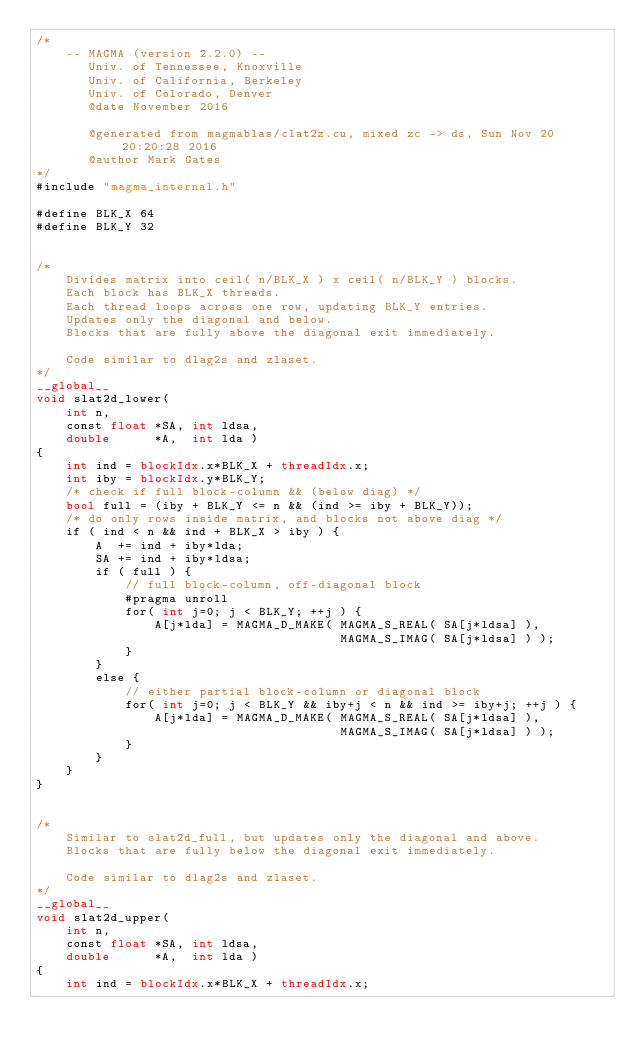Convert code to text. <code><loc_0><loc_0><loc_500><loc_500><_Cuda_>/*
    -- MAGMA (version 2.2.0) --
       Univ. of Tennessee, Knoxville
       Univ. of California, Berkeley
       Univ. of Colorado, Denver
       @date November 2016

       @generated from magmablas/clat2z.cu, mixed zc -> ds, Sun Nov 20 20:20:28 2016
       @author Mark Gates
*/
#include "magma_internal.h"

#define BLK_X 64
#define BLK_Y 32


/*
    Divides matrix into ceil( n/BLK_X ) x ceil( n/BLK_Y ) blocks.
    Each block has BLK_X threads.
    Each thread loops across one row, updating BLK_Y entries.
    Updates only the diagonal and below.
    Blocks that are fully above the diagonal exit immediately.
    
    Code similar to dlag2s and zlaset.
*/
__global__
void slat2d_lower(
    int n,
    const float *SA, int ldsa,
    double      *A,  int lda )
{
    int ind = blockIdx.x*BLK_X + threadIdx.x;
    int iby = blockIdx.y*BLK_Y;
    /* check if full block-column && (below diag) */
    bool full = (iby + BLK_Y <= n && (ind >= iby + BLK_Y));
    /* do only rows inside matrix, and blocks not above diag */
    if ( ind < n && ind + BLK_X > iby ) {
        A  += ind + iby*lda;
        SA += ind + iby*ldsa;
        if ( full ) {
            // full block-column, off-diagonal block
            #pragma unroll
            for( int j=0; j < BLK_Y; ++j ) {
                A[j*lda] = MAGMA_D_MAKE( MAGMA_S_REAL( SA[j*ldsa] ),
                                         MAGMA_S_IMAG( SA[j*ldsa] ) );
            }
        }
        else {
            // either partial block-column or diagonal block
            for( int j=0; j < BLK_Y && iby+j < n && ind >= iby+j; ++j ) {
                A[j*lda] = MAGMA_D_MAKE( MAGMA_S_REAL( SA[j*ldsa] ),
                                         MAGMA_S_IMAG( SA[j*ldsa] ) );
            }
        }
    }
}


/*
    Similar to slat2d_full, but updates only the diagonal and above.
    Blocks that are fully below the diagonal exit immediately.
    
    Code similar to dlag2s and zlaset.
*/
__global__
void slat2d_upper(
    int n,
    const float *SA, int ldsa,
    double      *A,  int lda )
{
    int ind = blockIdx.x*BLK_X + threadIdx.x;</code> 